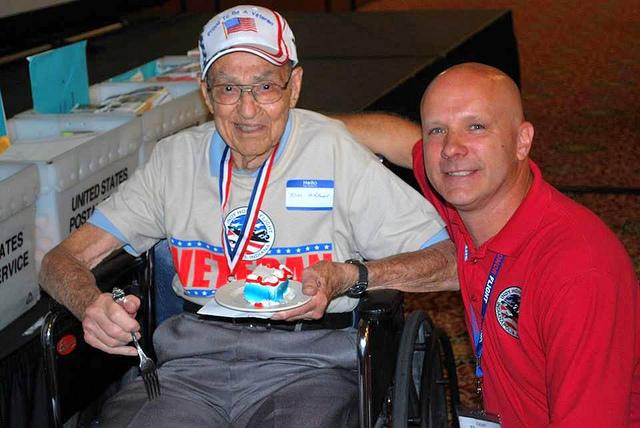How many people are wearing hats?
Keep it brief. 1. What did the man win?
Short answer required. Medal. How many faces can be seen?
Quick response, please. 2. What kind of boxes are in the background?
Write a very short answer. Postal boxes. How many men are shown?
Write a very short answer. 2. What kind of food does the man have?
Short answer required. Cake. 